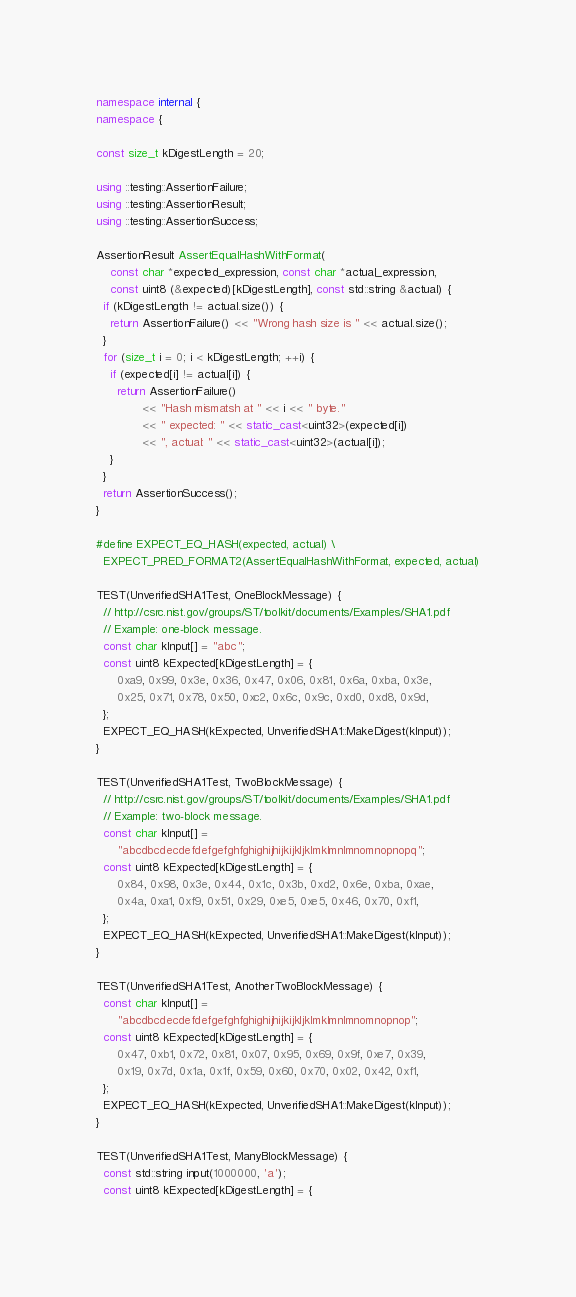<code> <loc_0><loc_0><loc_500><loc_500><_C++_>namespace internal {
namespace {

const size_t kDigestLength = 20;

using ::testing::AssertionFailure;
using ::testing::AssertionResult;
using ::testing::AssertionSuccess;

AssertionResult AssertEqualHashWithFormat(
    const char *expected_expression, const char *actual_expression,
    const uint8 (&expected)[kDigestLength], const std::string &actual) {
  if (kDigestLength != actual.size()) {
    return AssertionFailure() << "Wrong hash size is " << actual.size();
  }
  for (size_t i = 0; i < kDigestLength; ++i) {
    if (expected[i] != actual[i]) {
      return AssertionFailure()
             << "Hash mismatsh at " << i << " byte."
             << " expected: " << static_cast<uint32>(expected[i])
             << ", actual: " << static_cast<uint32>(actual[i]);
    }
  }
  return AssertionSuccess();
}

#define EXPECT_EQ_HASH(expected, actual) \
  EXPECT_PRED_FORMAT2(AssertEqualHashWithFormat, expected, actual)

TEST(UnverifiedSHA1Test, OneBlockMessage) {
  // http://csrc.nist.gov/groups/ST/toolkit/documents/Examples/SHA1.pdf
  // Example: one-block message.
  const char kInput[] = "abc";
  const uint8 kExpected[kDigestLength] = {
      0xa9, 0x99, 0x3e, 0x36, 0x47, 0x06, 0x81, 0x6a, 0xba, 0x3e,
      0x25, 0x71, 0x78, 0x50, 0xc2, 0x6c, 0x9c, 0xd0, 0xd8, 0x9d,
  };
  EXPECT_EQ_HASH(kExpected, UnverifiedSHA1::MakeDigest(kInput));
}

TEST(UnverifiedSHA1Test, TwoBlockMessage) {
  // http://csrc.nist.gov/groups/ST/toolkit/documents/Examples/SHA1.pdf
  // Example: two-block message.
  const char kInput[] =
      "abcdbcdecdefdefgefghfghighijhijkijkljklmklmnlmnomnopnopq";
  const uint8 kExpected[kDigestLength] = {
      0x84, 0x98, 0x3e, 0x44, 0x1c, 0x3b, 0xd2, 0x6e, 0xba, 0xae,
      0x4a, 0xa1, 0xf9, 0x51, 0x29, 0xe5, 0xe5, 0x46, 0x70, 0xf1,
  };
  EXPECT_EQ_HASH(kExpected, UnverifiedSHA1::MakeDigest(kInput));
}

TEST(UnverifiedSHA1Test, AnotherTwoBlockMessage) {
  const char kInput[] =
      "abcdbcdecdefdefgefghfghighijhijkijkljklmklmnlmnomnopnop";
  const uint8 kExpected[kDigestLength] = {
      0x47, 0xb1, 0x72, 0x81, 0x07, 0x95, 0x69, 0x9f, 0xe7, 0x39,
      0x19, 0x7d, 0x1a, 0x1f, 0x59, 0x60, 0x70, 0x02, 0x42, 0xf1,
  };
  EXPECT_EQ_HASH(kExpected, UnverifiedSHA1::MakeDigest(kInput));
}

TEST(UnverifiedSHA1Test, ManyBlockMessage) {
  const std::string input(1000000, 'a');
  const uint8 kExpected[kDigestLength] = {</code> 